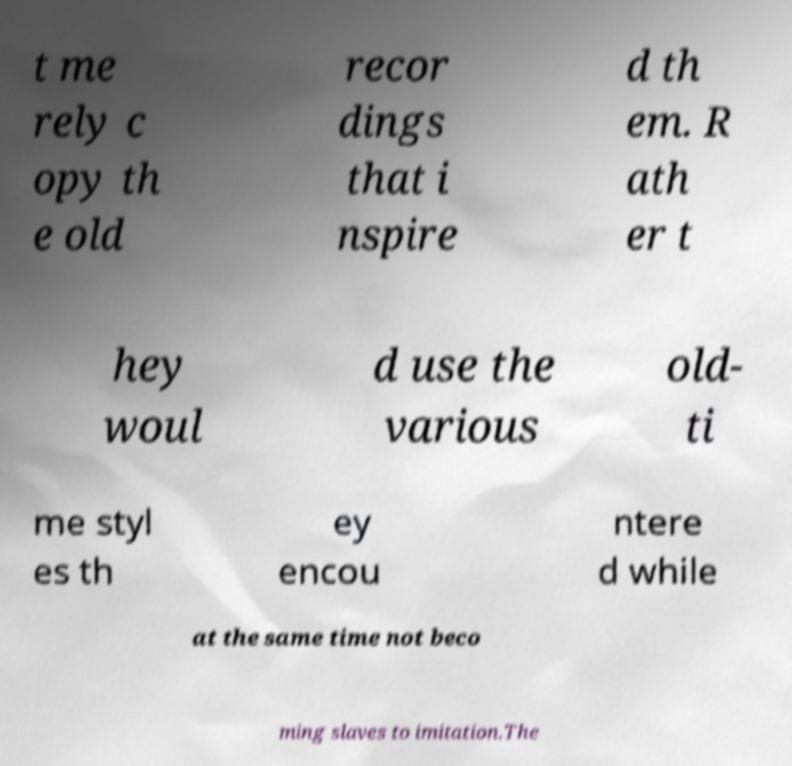Could you assist in decoding the text presented in this image and type it out clearly? t me rely c opy th e old recor dings that i nspire d th em. R ath er t hey woul d use the various old- ti me styl es th ey encou ntere d while at the same time not beco ming slaves to imitation.The 